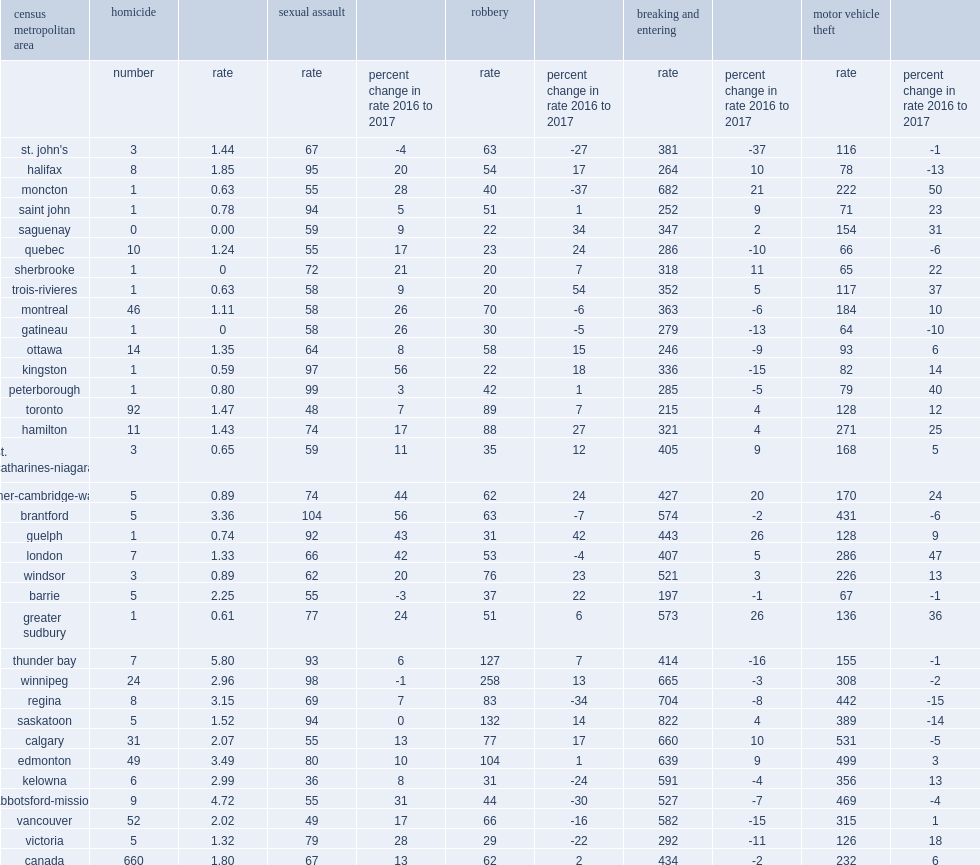Which cma recorded the highest homicide rate among the cmas in 2017? Thunder bay. List the top3 cmas with the largest increases in robbery rates. Trois-rivieres guelph saguenay. List the top3 cmas with the largest decreases in rates of robbery in 2017. Moncton regina abbotsford-mission. 